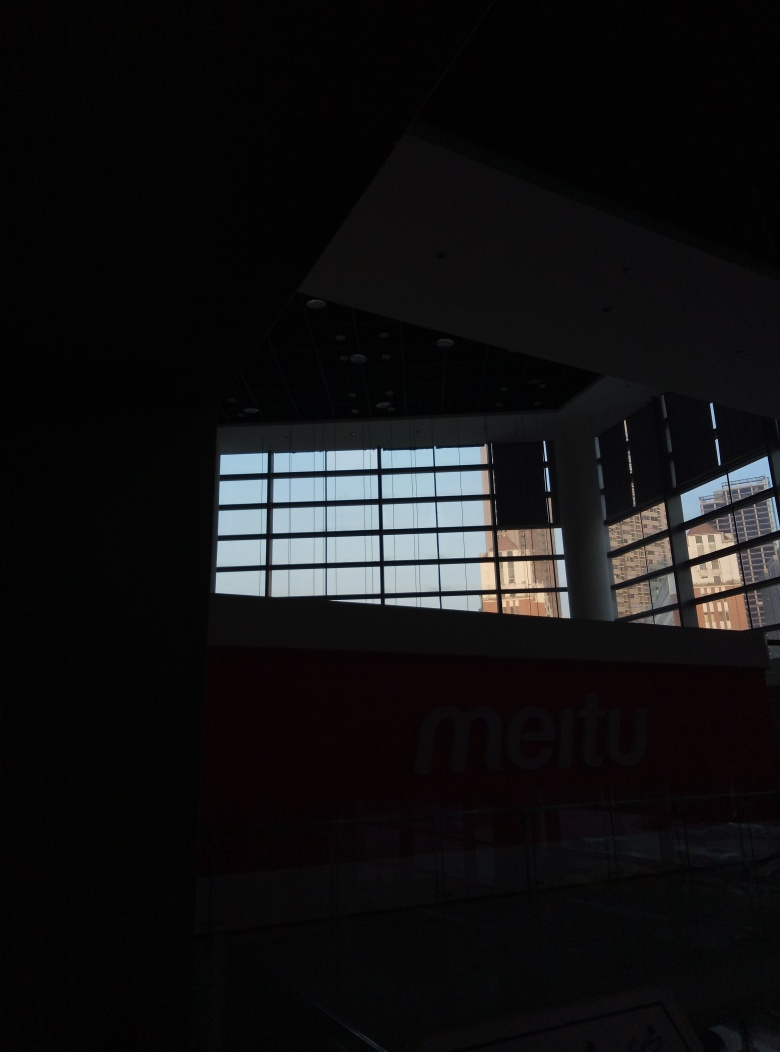Can you describe the architectural style or elements visible in the photo? The architectural elements in the photo suggest a modern, minimalistic style. Notable features include the geometric lines of the windows, the grid pattern they form, and the sharp contrast they create against the dark ceiling. The use of large glass panes allows ample natural light, indicating a design that may prioritize open, well-lit spaces. 